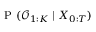Convert formula to latex. <formula><loc_0><loc_0><loc_500><loc_500>P ( \mathcal { O } _ { 1 \colon K } | X _ { 0 \colon T } )</formula> 